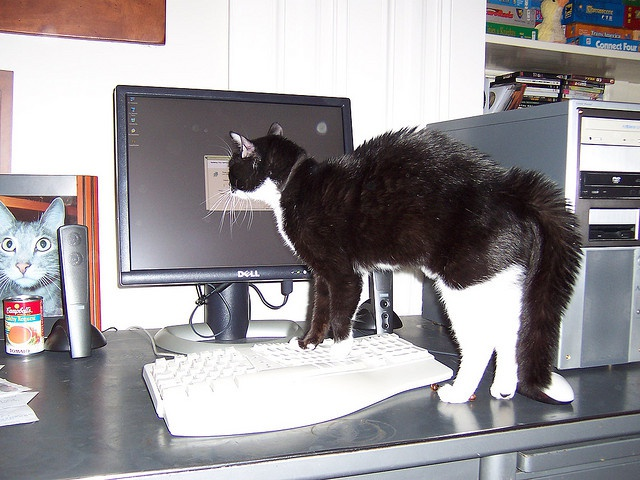Describe the objects in this image and their specific colors. I can see cat in brown, black, white, and gray tones, tv in brown, gray, darkgray, lightgray, and black tones, keyboard in brown, white, darkgray, and gray tones, book in brown, lightgray, darkgray, lightblue, and gray tones, and book in brown, gray, black, and darkgray tones in this image. 